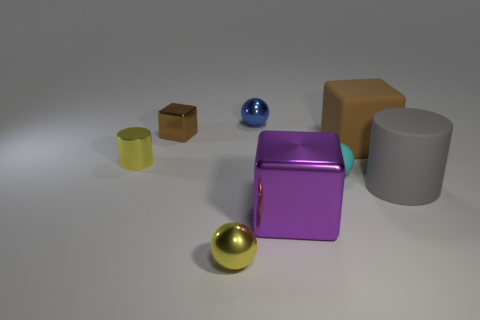There is a metallic object that is the same shape as the large gray matte thing; what is its size?
Make the answer very short. Small. Is the color of the metallic object that is left of the small brown shiny object the same as the tiny metallic object that is in front of the metal cylinder?
Your answer should be very brief. Yes. Are there any large purple blocks right of the small blue object?
Provide a succinct answer. Yes. What color is the big rubber block right of the tiny thing in front of the large gray cylinder behind the purple object?
Offer a terse response. Brown. What is the shape of the gray matte object that is the same size as the brown rubber object?
Offer a very short reply. Cylinder. Is the number of shiny blocks greater than the number of yellow cylinders?
Your answer should be compact. Yes. There is a large thing that is behind the small cyan rubber sphere; is there a thing that is behind it?
Your answer should be compact. Yes. There is another big object that is the same shape as the brown rubber thing; what is its color?
Provide a succinct answer. Purple. There is a cylinder that is made of the same material as the tiny block; what is its color?
Your answer should be very brief. Yellow. There is a shiny cube behind the small cyan ball behind the gray rubber object; is there a cyan thing that is to the left of it?
Offer a terse response. No. 